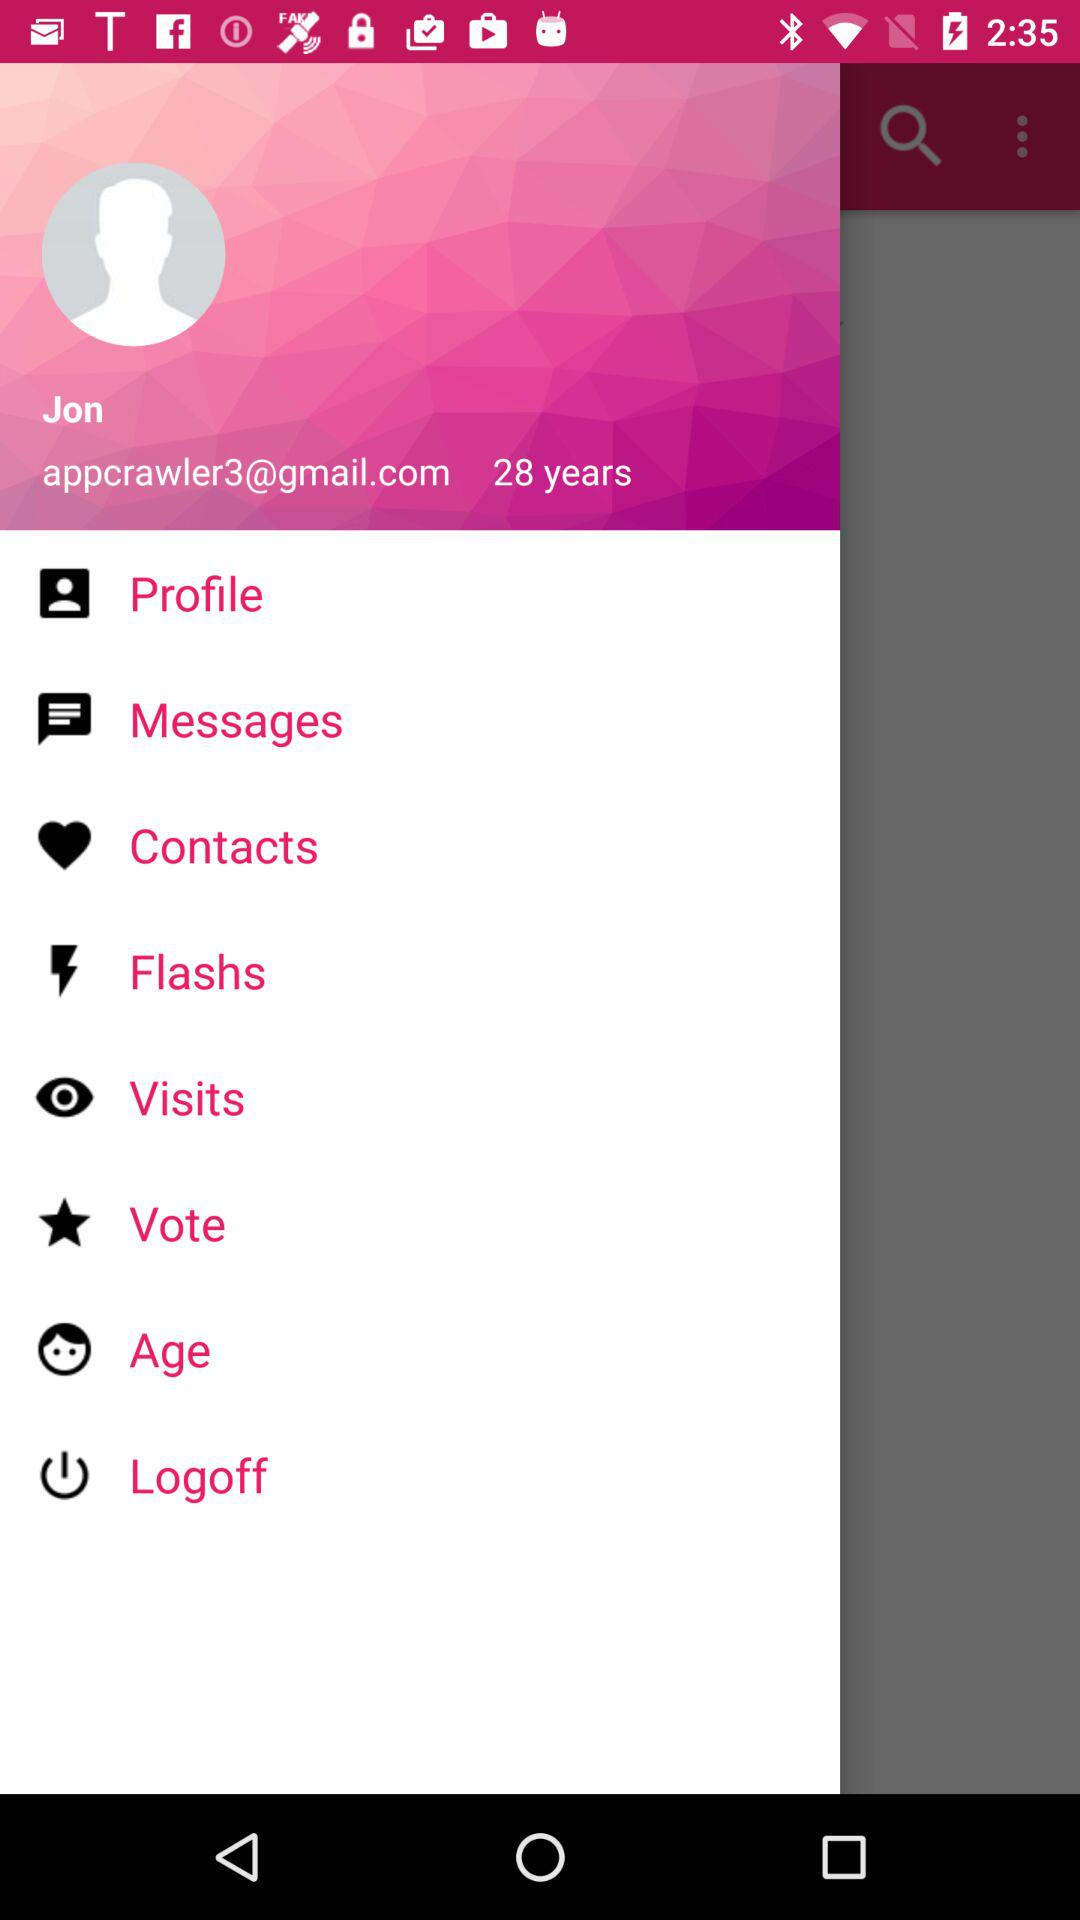What is the email address? The email address is appcrawler3@gmail.com. 